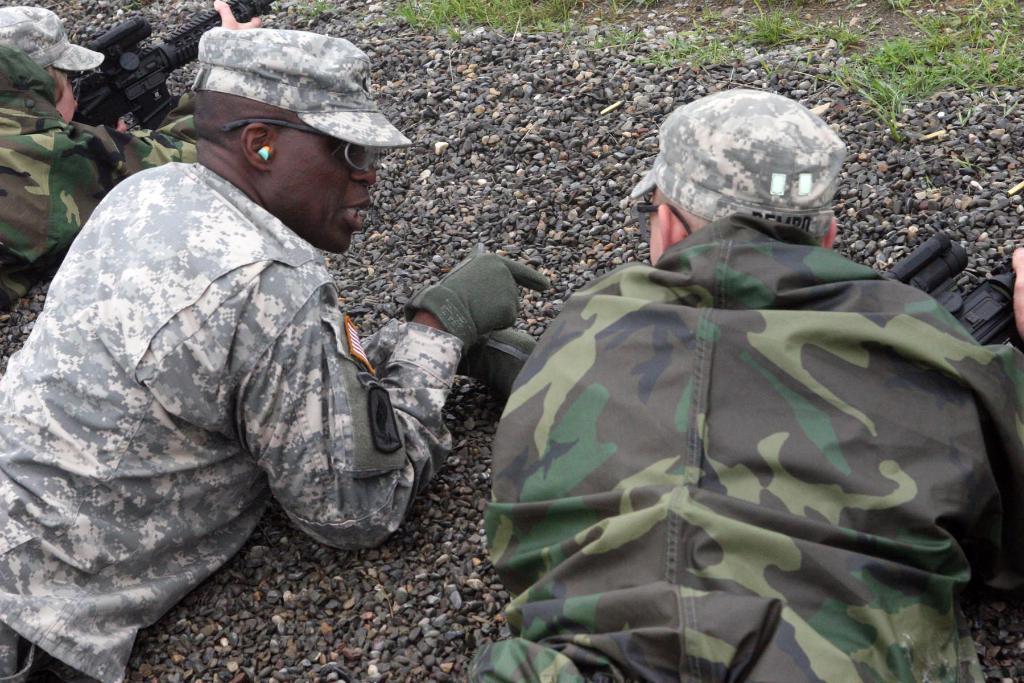Describe this image in one or two sentences. Three persons are lying on stones. They are wearing caps and goggles. Two are holding guns. On the ground there is grass. 